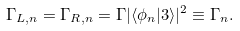<formula> <loc_0><loc_0><loc_500><loc_500>\Gamma _ { L , n } = \Gamma _ { R , n } = \Gamma | \langle \phi _ { n } | 3 \rangle | ^ { 2 } \equiv \Gamma _ { n } .</formula> 